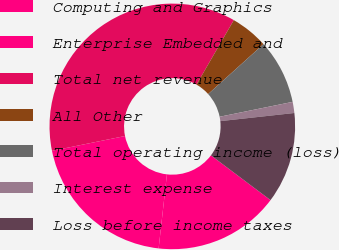Convert chart to OTSL. <chart><loc_0><loc_0><loc_500><loc_500><pie_chart><fcel>Computing and Graphics<fcel>Enterprise Embedded and<fcel>Total net revenue<fcel>All Other<fcel>Total operating income (loss)<fcel>Interest expense<fcel>Loss before income taxes<nl><fcel>16.53%<fcel>20.03%<fcel>36.54%<fcel>4.97%<fcel>8.48%<fcel>1.46%<fcel>11.99%<nl></chart> 